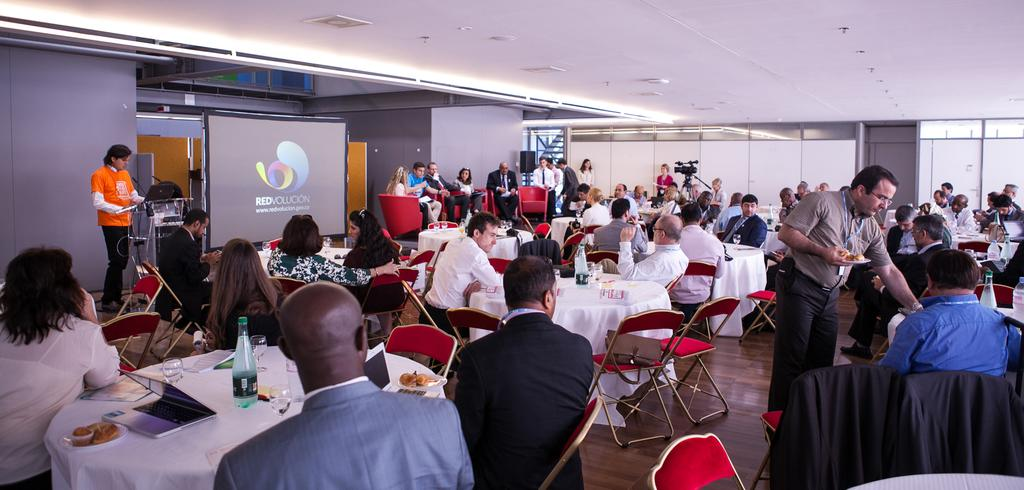What are the people near the table doing in the image? The people sitting on chairs near a table are likely participating in a meeting or presentation. What is the person standing at the podium doing? The person standing at the podium is likely presenting or speaking to the group. What is the purpose of the projector screen in the image? The projector screen is likely being used to display visual aids or presentations during the meeting or presentation. What device is being used to amplify the speaker's voice? There is a speaker present in the image, which is being used to amplify the speaker's voice. What device is being used to record the event? A video camera is visible in the image, which is likely being used to record the event. What type of patch is being sewn onto the pet's collar in the image? There is no patch or pet present in the image; it features people sitting on chairs near a table, a person standing at a podium, a projector screen, a speaker, and a video camera. 